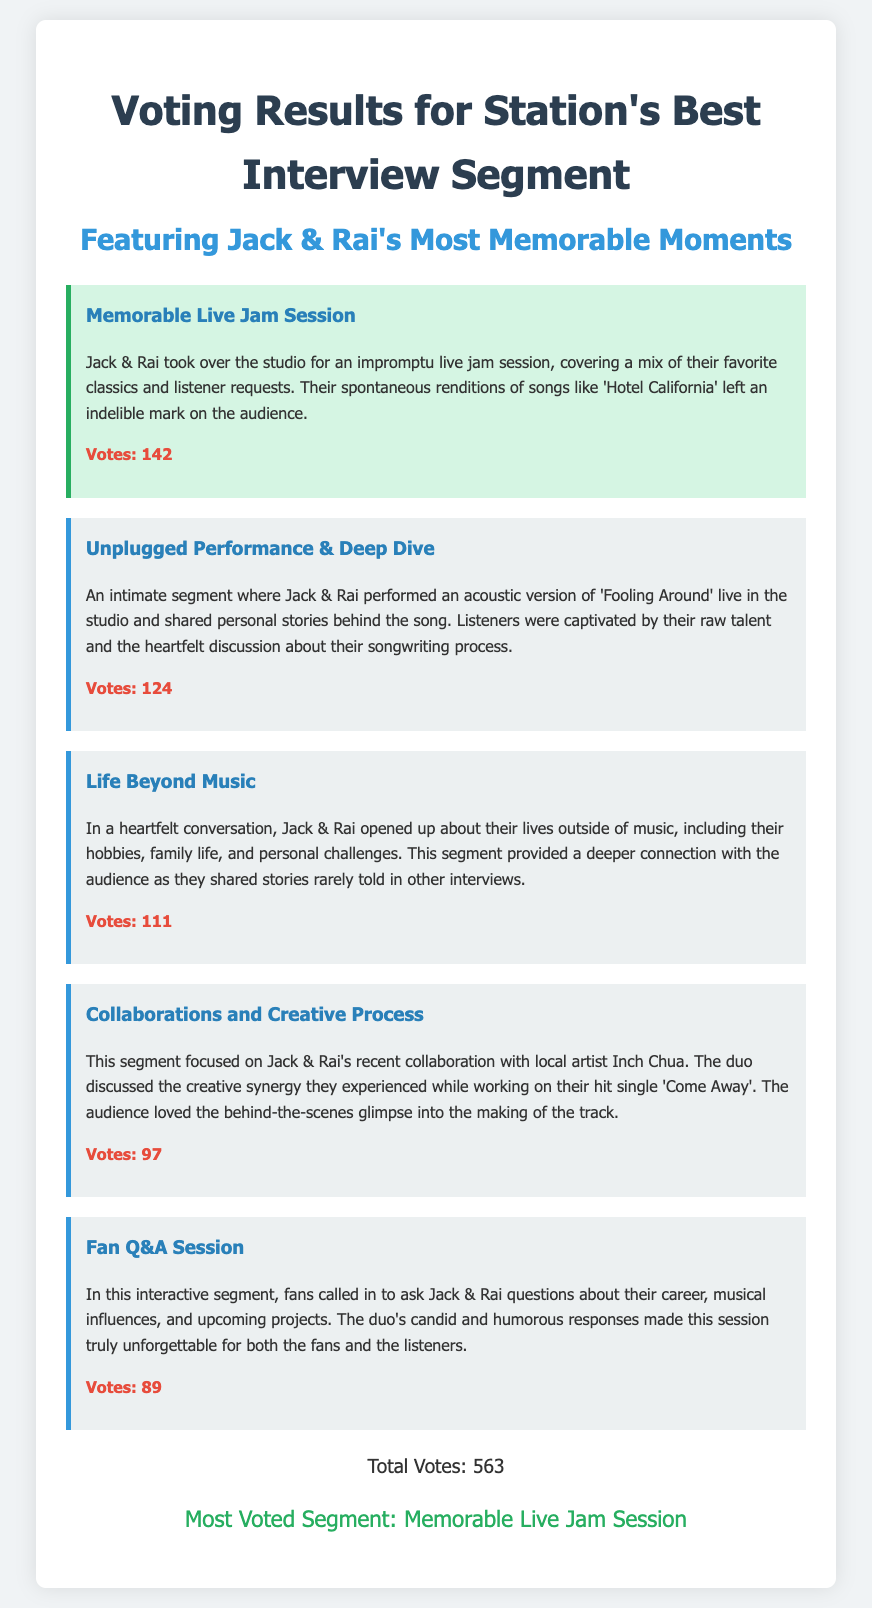What is the title of the most voted segment? The title of the most voted segment can be found under the "most voted" section in the document.
Answer: Memorable Live Jam Session How many votes did the Unplugged Performance & Deep Dive segment receive? The votes for each segment are listed alongside their descriptions, and the number for this segment is specifically noted.
Answer: 124 What is the total number of votes cast? The total votes are summarized at the bottom of the document.
Answer: 563 Which segment featured an acoustic performance of 'Fooling Around'? This information is specified in the description of the Unplugged Performance & Deep Dive segment.
Answer: Unplugged Performance & Deep Dive Which segment discussed Jack & Rai's collaboration with Inch Chua? The collaboration segment's description makes it clear that it focuses on their work with Inch Chua.
Answer: Collaborations and Creative Process What was the theme of the Life Beyond Music segment? The theme can be gleaned from the description of the Life Beyond Music segment.
Answer: Personal lives outside music How many votes did the Fan Q&A Session receive? The votes for this specific segment are provided in the document.
Answer: 89 What was unique about the Memorable Live Jam Session? The uniqueness of this segment is described in the context of its spontaneous live performance.
Answer: Impromptu live jam session What is the total number of segments listed? The total number can be counted based on the number of segments detailed in the document.
Answer: 5 